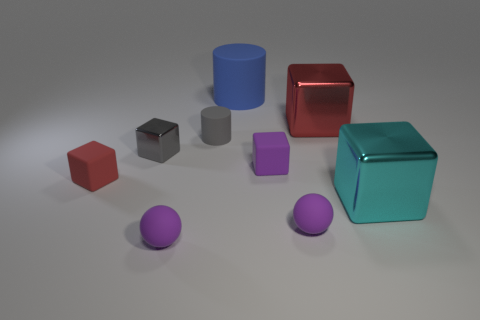How many things are either tiny purple blocks or large metal cubes?
Ensure brevity in your answer.  3. What number of things have the same material as the gray cube?
Provide a succinct answer. 2. There is another rubber object that is the same shape as the tiny gray matte thing; what is its size?
Keep it short and to the point. Large. There is a cyan metal object; are there any red shiny things in front of it?
Your answer should be compact. No. What is the purple block made of?
Your answer should be compact. Rubber. There is a block that is to the left of the small gray cube; is it the same color as the small cylinder?
Give a very brief answer. No. Is there any other thing that has the same shape as the gray matte object?
Provide a short and direct response. Yes. What color is the tiny shiny thing that is the same shape as the red rubber thing?
Your answer should be compact. Gray. There is a red object that is in front of the tiny gray shiny cube; what material is it?
Keep it short and to the point. Rubber. The small cylinder is what color?
Your answer should be compact. Gray. 